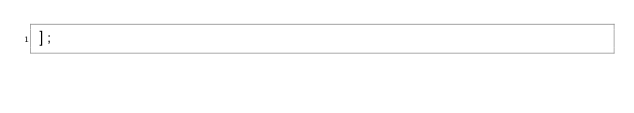Convert code to text. <code><loc_0><loc_0><loc_500><loc_500><_JavaScript_>];</code> 